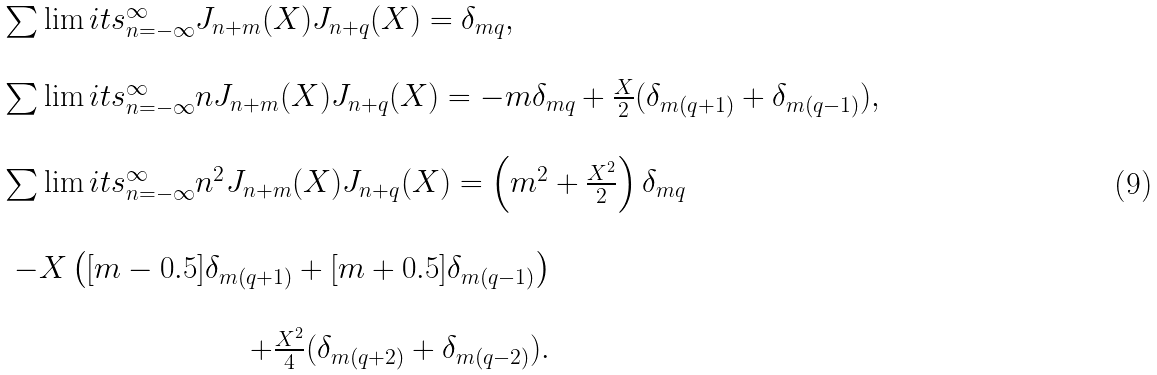Convert formula to latex. <formula><loc_0><loc_0><loc_500><loc_500>\begin{array} { l } \sum \lim i t s _ { n = - \infty } ^ { \infty } J _ { n + m } ( X ) J _ { n + q } ( X ) = \delta _ { m q } , \\ \ \\ \sum \lim i t s _ { n = - \infty } ^ { \infty } n J _ { n + m } ( X ) J _ { n + q } ( X ) = - m \delta _ { m q } + \frac { X } { 2 } ( \delta _ { m ( q + 1 ) } + \delta _ { m ( q - 1 ) } ) , \\ \ \\ \sum \lim i t s _ { n = - \infty } ^ { \infty } n ^ { 2 } J _ { n + m } ( X ) J _ { n + q } ( X ) = \left ( m ^ { 2 } + \frac { X ^ { 2 } } { 2 } \right ) \delta _ { m q } \\ \ \\ \begin{array} { r } - X \left ( [ m - 0 . 5 ] \delta _ { m ( q + 1 ) } + [ m + 0 . 5 ] \delta _ { m ( q - 1 ) } \right ) \\ \ \\ + \frac { X ^ { 2 } } { 4 } ( \delta _ { m ( q + 2 ) } + \delta _ { m ( q - 2 ) } ) . \end{array} \end{array}</formula> 